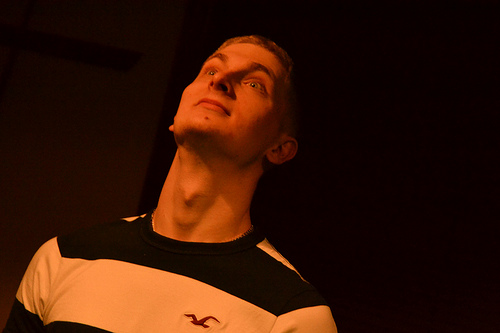<image>
Is there a person in front of the shirt? No. The person is not in front of the shirt. The spatial positioning shows a different relationship between these objects. 